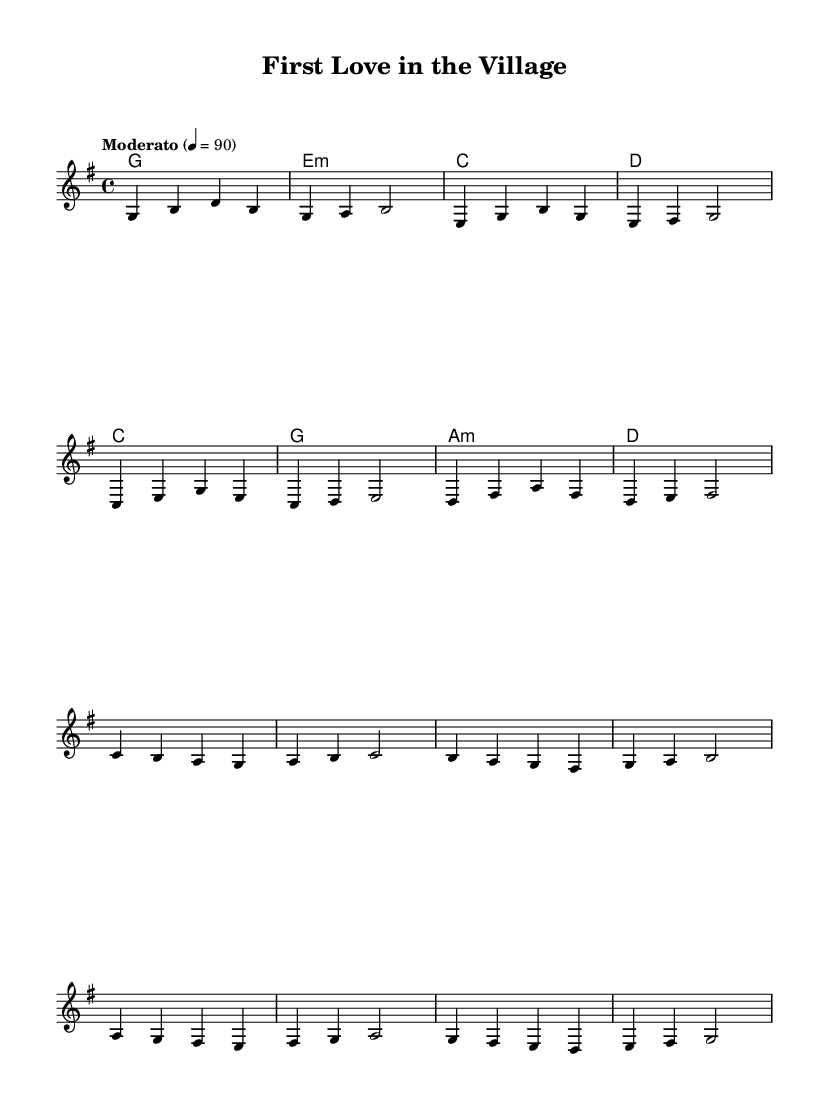What is the key signature of this music? The key signature is G major, which has one sharp (F#) indicated by the presence of the sharp symbol next to the F line on the staff.
Answer: G major What is the time signature of this music? The time signature is 4/4, which means there are four beats in each measure and a quarter note receives one beat. This is indicated at the beginning of the staff before the notes.
Answer: 4/4 What is the tempo marking of this piece? The tempo marking is "Moderato," which refers to a moderate speed in music, and the associated metronome marking (4 = 90) specifies a speed of 90 beats per minute.
Answer: Moderato How many measures are in the verse section? The verse section contains 8 measures, as counted by each line in the melody notation, where each line represents a grouping of measures.
Answer: 8 What is the main theme expressed in the lyrics? The main theme expressed in the lyrics revolves around young love, highlighted by phrases like "love at first sight" and the sentiment of "pure and true." These lyrics convey affection and innocence associated with first love experiences.
Answer: Young love What type of chords are used in the harmonies? The chords used are a mix of major and minor chords, specifically G major, E minor, C major, and D major, which provide a rich harmonic background to the melody, characteristic of acoustic ballads.
Answer: Major and minor What is the structure of the song concerning verses and chorus? The song follows a structure where there is a verse followed by a chorus, demonstrating a common pattern in storytelling songwriting, effectively alternating between narrative and emotional expressions.
Answer: Verse - Chorus 